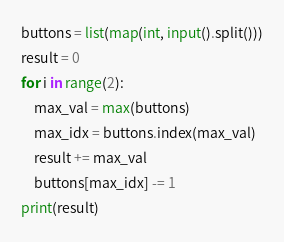<code> <loc_0><loc_0><loc_500><loc_500><_Python_>buttons = list(map(int, input().split()))
result = 0
for i in range(2):
    max_val = max(buttons)
    max_idx = buttons.index(max_val)
    result += max_val
    buttons[max_idx] -= 1
print(result)</code> 